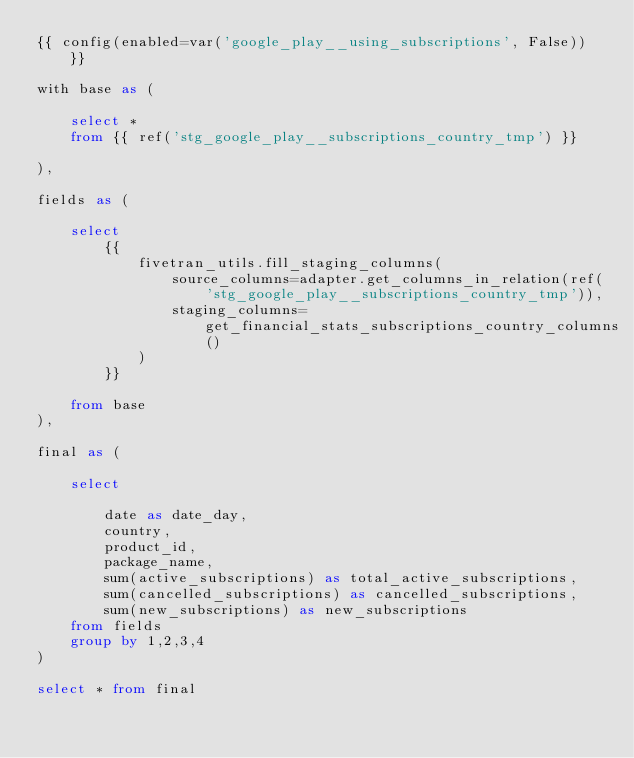Convert code to text. <code><loc_0><loc_0><loc_500><loc_500><_SQL_>{{ config(enabled=var('google_play__using_subscriptions', False)) }}

with base as (

    select * 
    from {{ ref('stg_google_play__subscriptions_country_tmp') }}

),

fields as (

    select
        {{
            fivetran_utils.fill_staging_columns(
                source_columns=adapter.get_columns_in_relation(ref('stg_google_play__subscriptions_country_tmp')),
                staging_columns=get_financial_stats_subscriptions_country_columns()
            )
        }}
        
    from base
),

final as (
    
    select 

        date as date_day,
        country,
        product_id,
        package_name,
        sum(active_subscriptions) as total_active_subscriptions,
        sum(cancelled_subscriptions) as cancelled_subscriptions,
        sum(new_subscriptions) as new_subscriptions
    from fields
    group by 1,2,3,4
)

select * from final
</code> 